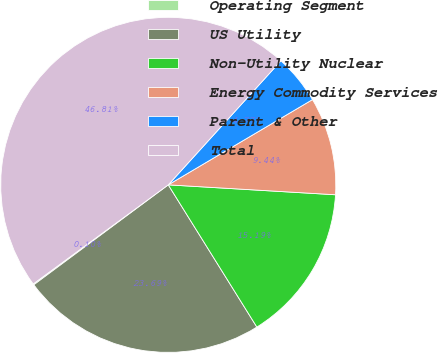Convert chart to OTSL. <chart><loc_0><loc_0><loc_500><loc_500><pie_chart><fcel>Operating Segment<fcel>US Utility<fcel>Non-Utility Nuclear<fcel>Energy Commodity Services<fcel>Parent & Other<fcel>Total<nl><fcel>0.1%<fcel>23.69%<fcel>15.19%<fcel>9.44%<fcel>4.77%<fcel>46.81%<nl></chart> 